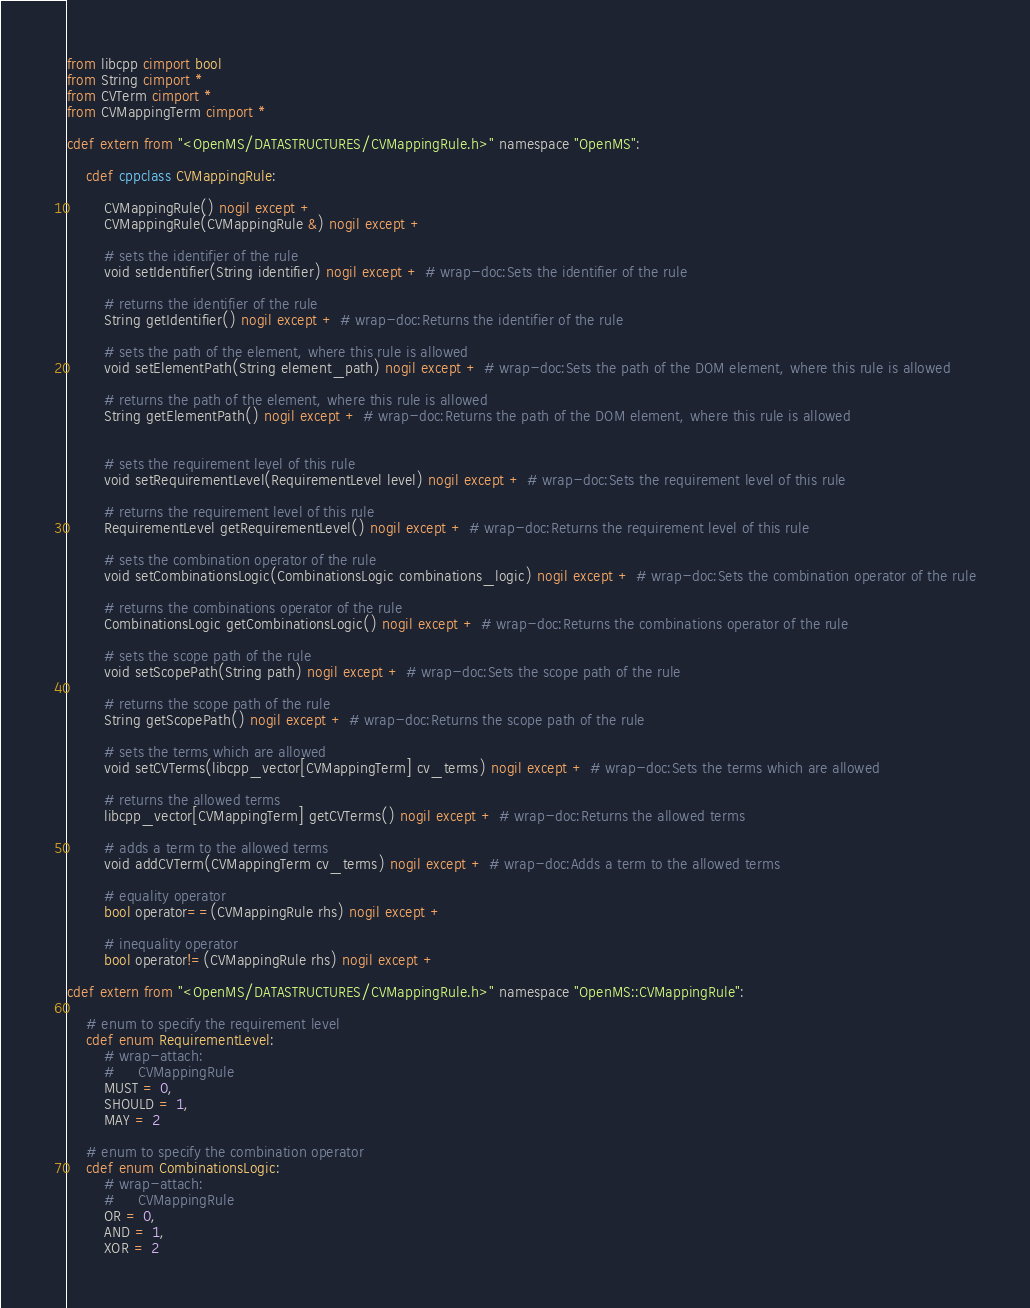Convert code to text. <code><loc_0><loc_0><loc_500><loc_500><_Cython_>from libcpp cimport bool
from String cimport *
from CVTerm cimport *
from CVMappingTerm cimport *

cdef extern from "<OpenMS/DATASTRUCTURES/CVMappingRule.h>" namespace "OpenMS":

    cdef cppclass CVMappingRule:

        CVMappingRule() nogil except +
        CVMappingRule(CVMappingRule &) nogil except +

        # sets the identifier of the rule
        void setIdentifier(String identifier) nogil except + # wrap-doc:Sets the identifier of the rule

        # returns the identifier of the rule
        String getIdentifier() nogil except + # wrap-doc:Returns the identifier of the rule

        # sets the path of the element, where this rule is allowed
        void setElementPath(String element_path) nogil except + # wrap-doc:Sets the path of the DOM element, where this rule is allowed

        # returns the path of the element, where this rule is allowed
        String getElementPath() nogil except + # wrap-doc:Returns the path of the DOM element, where this rule is allowed


        # sets the requirement level of this rule
        void setRequirementLevel(RequirementLevel level) nogil except + # wrap-doc:Sets the requirement level of this rule

        # returns the requirement level of this rule
        RequirementLevel getRequirementLevel() nogil except + # wrap-doc:Returns the requirement level of this rule

        # sets the combination operator of the rule
        void setCombinationsLogic(CombinationsLogic combinations_logic) nogil except + # wrap-doc:Sets the combination operator of the rule

        # returns the combinations operator of the rule
        CombinationsLogic getCombinationsLogic() nogil except + # wrap-doc:Returns the combinations operator of the rule

        # sets the scope path of the rule
        void setScopePath(String path) nogil except + # wrap-doc:Sets the scope path of the rule

        # returns the scope path of the rule
        String getScopePath() nogil except + # wrap-doc:Returns the scope path of the rule

        # sets the terms which are allowed
        void setCVTerms(libcpp_vector[CVMappingTerm] cv_terms) nogil except + # wrap-doc:Sets the terms which are allowed

        # returns the allowed terms
        libcpp_vector[CVMappingTerm] getCVTerms() nogil except + # wrap-doc:Returns the allowed terms

        # adds a term to the allowed terms
        void addCVTerm(CVMappingTerm cv_terms) nogil except + # wrap-doc:Adds a term to the allowed terms

        # equality operator
        bool operator==(CVMappingRule rhs) nogil except +

        # inequality operator
        bool operator!=(CVMappingRule rhs) nogil except +

cdef extern from "<OpenMS/DATASTRUCTURES/CVMappingRule.h>" namespace "OpenMS::CVMappingRule":

    # enum to specify the requirement level
    cdef enum RequirementLevel:
        # wrap-attach:
        #     CVMappingRule
        MUST = 0,
        SHOULD = 1,
        MAY = 2

    # enum to specify the combination operator
    cdef enum CombinationsLogic:
        # wrap-attach:
        #     CVMappingRule
        OR = 0,
        AND = 1,
        XOR = 2
</code> 